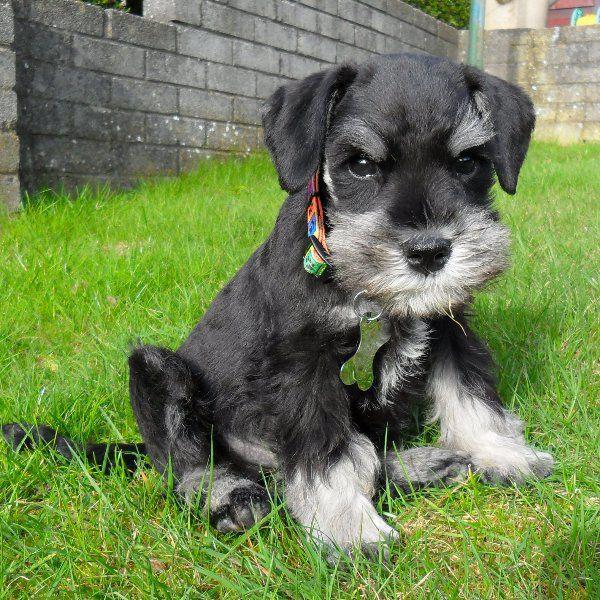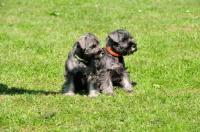The first image is the image on the left, the second image is the image on the right. Examine the images to the left and right. Is the description "a dog is standing in the grass with a taught leash" accurate? Answer yes or no. No. The first image is the image on the left, the second image is the image on the right. Evaluate the accuracy of this statement regarding the images: "A long haired light colored dog is standing outside in the grass on a leash.". Is it true? Answer yes or no. No. 